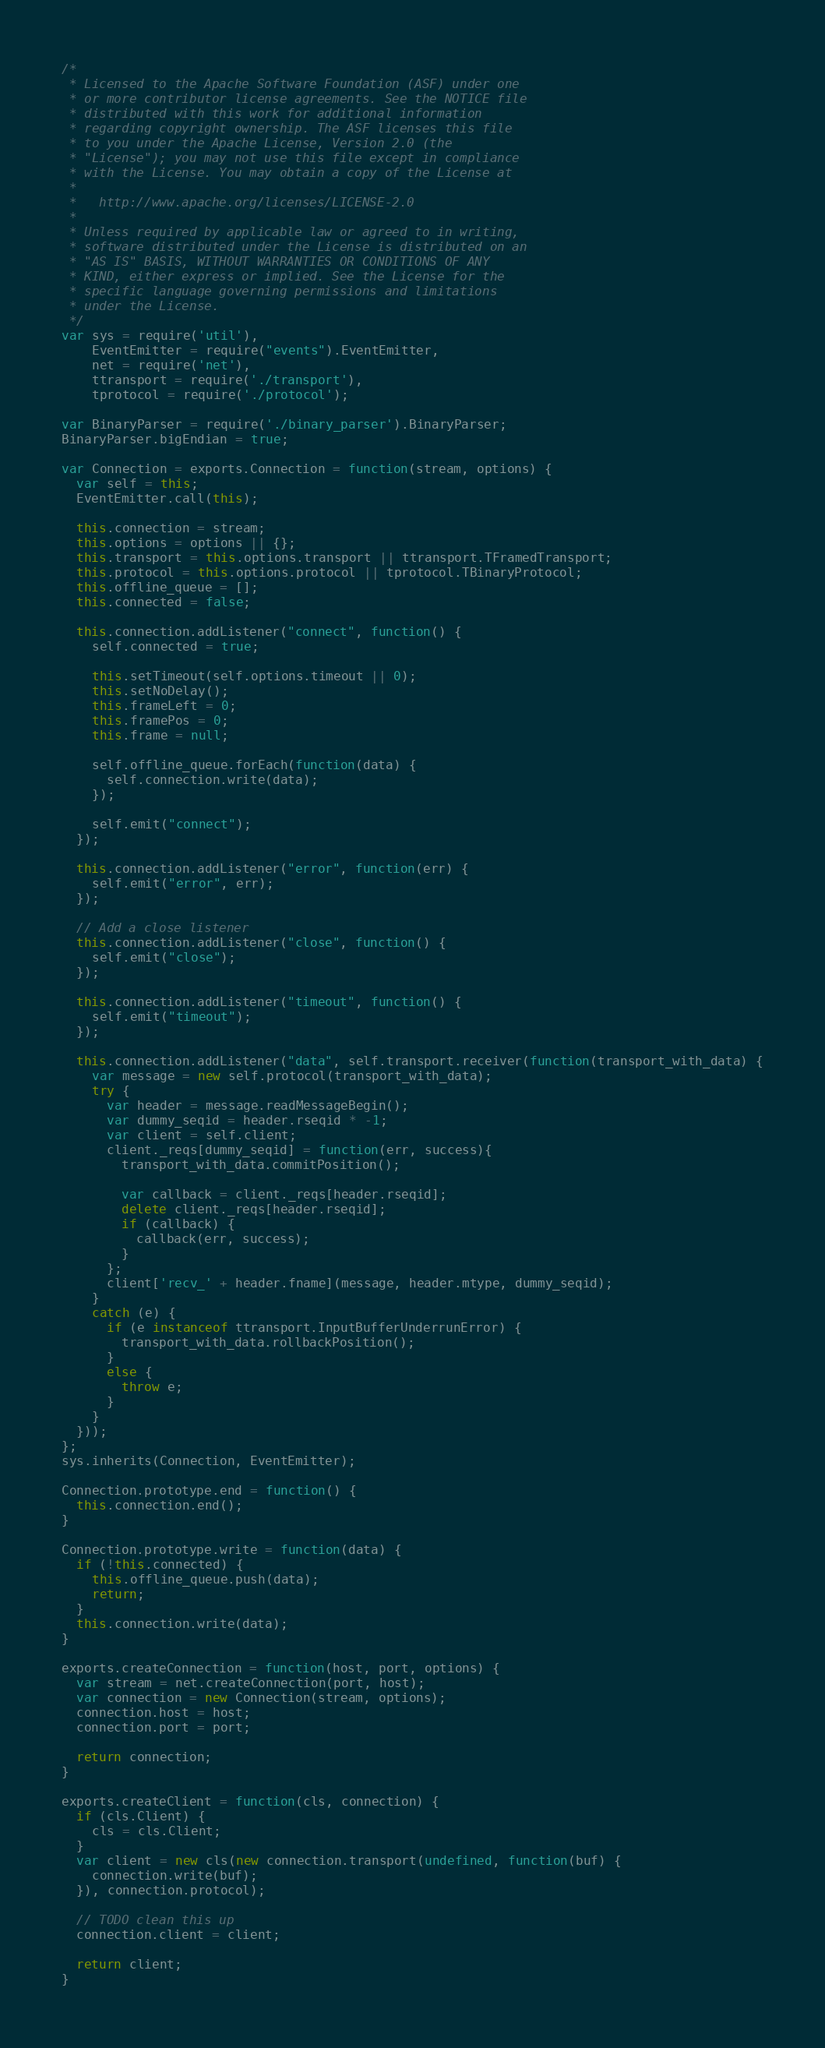<code> <loc_0><loc_0><loc_500><loc_500><_JavaScript_>/*
 * Licensed to the Apache Software Foundation (ASF) under one
 * or more contributor license agreements. See the NOTICE file
 * distributed with this work for additional information
 * regarding copyright ownership. The ASF licenses this file
 * to you under the Apache License, Version 2.0 (the
 * "License"); you may not use this file except in compliance
 * with the License. You may obtain a copy of the License at
 *
 *   http://www.apache.org/licenses/LICENSE-2.0
 *
 * Unless required by applicable law or agreed to in writing,
 * software distributed under the License is distributed on an
 * "AS IS" BASIS, WITHOUT WARRANTIES OR CONDITIONS OF ANY
 * KIND, either express or implied. See the License for the
 * specific language governing permissions and limitations
 * under the License.
 */
var sys = require('util'),
    EventEmitter = require("events").EventEmitter,
    net = require('net'),
    ttransport = require('./transport'),
    tprotocol = require('./protocol');

var BinaryParser = require('./binary_parser').BinaryParser;
BinaryParser.bigEndian = true;

var Connection = exports.Connection = function(stream, options) {
  var self = this;
  EventEmitter.call(this);

  this.connection = stream;
  this.options = options || {};
  this.transport = this.options.transport || ttransport.TFramedTransport;
  this.protocol = this.options.protocol || tprotocol.TBinaryProtocol;
  this.offline_queue = [];
  this.connected = false;

  this.connection.addListener("connect", function() {
    self.connected = true;

    this.setTimeout(self.options.timeout || 0);
    this.setNoDelay();
    this.frameLeft = 0;
    this.framePos = 0;
    this.frame = null;

    self.offline_queue.forEach(function(data) {
      self.connection.write(data);
    });

    self.emit("connect");
  });

  this.connection.addListener("error", function(err) {
    self.emit("error", err);
  });

  // Add a close listener
  this.connection.addListener("close", function() {
    self.emit("close");
  });

  this.connection.addListener("timeout", function() {
    self.emit("timeout");
  });

  this.connection.addListener("data", self.transport.receiver(function(transport_with_data) {
    var message = new self.protocol(transport_with_data);
    try {
      var header = message.readMessageBegin();
      var dummy_seqid = header.rseqid * -1;
      var client = self.client;
      client._reqs[dummy_seqid] = function(err, success){
        transport_with_data.commitPosition();

        var callback = client._reqs[header.rseqid];
        delete client._reqs[header.rseqid];
        if (callback) {
          callback(err, success);
        }
      };
      client['recv_' + header.fname](message, header.mtype, dummy_seqid);
    }
    catch (e) {
      if (e instanceof ttransport.InputBufferUnderrunError) {
        transport_with_data.rollbackPosition();
      }
      else {
        throw e;
      }
    }
  }));
};
sys.inherits(Connection, EventEmitter);

Connection.prototype.end = function() {
  this.connection.end();
}

Connection.prototype.write = function(data) {
  if (!this.connected) {
    this.offline_queue.push(data);
    return;
  }
  this.connection.write(data);
}

exports.createConnection = function(host, port, options) {
  var stream = net.createConnection(port, host);
  var connection = new Connection(stream, options);
  connection.host = host;
  connection.port = port;

  return connection;
}

exports.createClient = function(cls, connection) {
  if (cls.Client) {
    cls = cls.Client;
  }
  var client = new cls(new connection.transport(undefined, function(buf) {
    connection.write(buf);
  }), connection.protocol);

  // TODO clean this up
  connection.client = client;

  return client;
}
</code> 